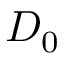<formula> <loc_0><loc_0><loc_500><loc_500>D _ { 0 }</formula> 